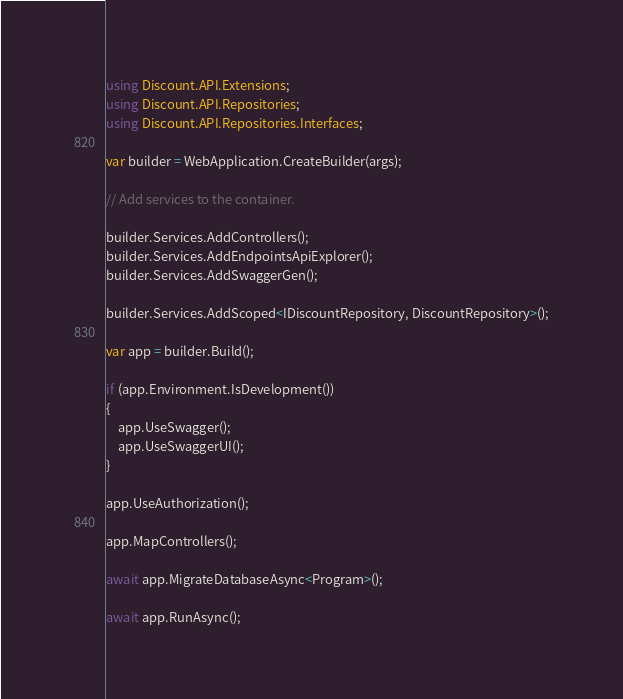Convert code to text. <code><loc_0><loc_0><loc_500><loc_500><_C#_>using Discount.API.Extensions;
using Discount.API.Repositories;
using Discount.API.Repositories.Interfaces;

var builder = WebApplication.CreateBuilder(args);

// Add services to the container.

builder.Services.AddControllers();
builder.Services.AddEndpointsApiExplorer();
builder.Services.AddSwaggerGen();

builder.Services.AddScoped<IDiscountRepository, DiscountRepository>();

var app = builder.Build();

if (app.Environment.IsDevelopment())
{
    app.UseSwagger();
    app.UseSwaggerUI();
}

app.UseAuthorization();

app.MapControllers();

await app.MigrateDatabaseAsync<Program>();

await app.RunAsync();
</code> 